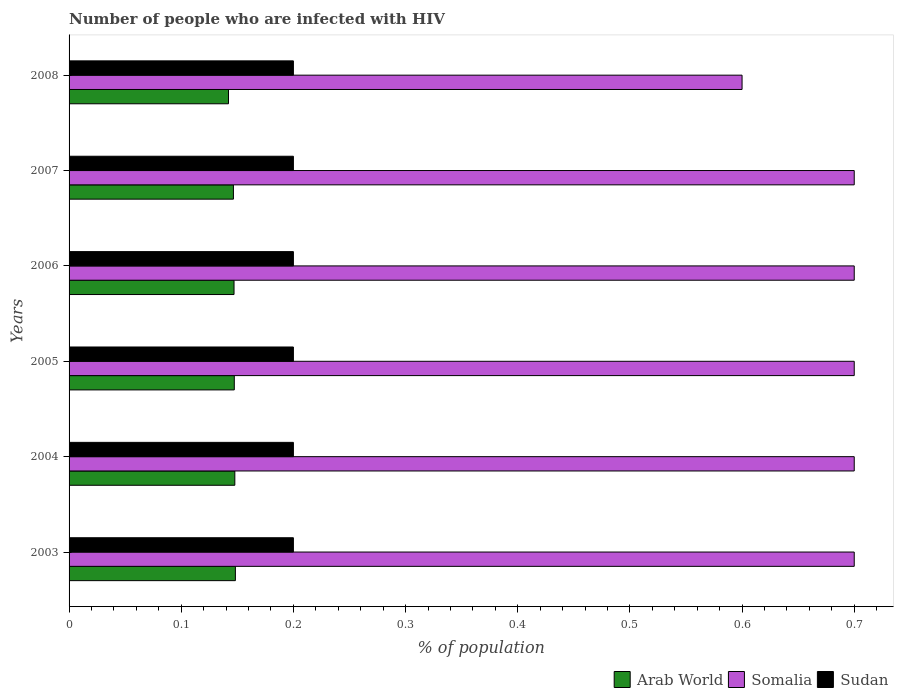How many different coloured bars are there?
Give a very brief answer. 3. Are the number of bars on each tick of the Y-axis equal?
Keep it short and to the point. Yes. How many bars are there on the 6th tick from the bottom?
Your answer should be compact. 3. What is the label of the 1st group of bars from the top?
Provide a succinct answer. 2008. What is the percentage of HIV infected population in in Arab World in 2003?
Your response must be concise. 0.15. In which year was the percentage of HIV infected population in in Sudan maximum?
Make the answer very short. 2003. In which year was the percentage of HIV infected population in in Sudan minimum?
Offer a very short reply. 2003. What is the total percentage of HIV infected population in in Arab World in the graph?
Offer a very short reply. 0.88. What is the difference between the percentage of HIV infected population in in Somalia in 2003 and that in 2005?
Your answer should be compact. 0. What is the difference between the percentage of HIV infected population in in Sudan in 2006 and the percentage of HIV infected population in in Arab World in 2007?
Make the answer very short. 0.05. What is the average percentage of HIV infected population in in Sudan per year?
Provide a short and direct response. 0.2. In the year 2006, what is the difference between the percentage of HIV infected population in in Somalia and percentage of HIV infected population in in Sudan?
Your answer should be very brief. 0.5. What is the difference between the highest and the lowest percentage of HIV infected population in in Arab World?
Make the answer very short. 0.01. Is the sum of the percentage of HIV infected population in in Sudan in 2003 and 2004 greater than the maximum percentage of HIV infected population in in Somalia across all years?
Make the answer very short. No. What does the 2nd bar from the top in 2008 represents?
Provide a short and direct response. Somalia. What does the 2nd bar from the bottom in 2003 represents?
Your answer should be very brief. Somalia. How many bars are there?
Your answer should be very brief. 18. Are the values on the major ticks of X-axis written in scientific E-notation?
Provide a succinct answer. No. Does the graph contain grids?
Your answer should be compact. No. How many legend labels are there?
Offer a terse response. 3. How are the legend labels stacked?
Provide a succinct answer. Horizontal. What is the title of the graph?
Provide a short and direct response. Number of people who are infected with HIV. What is the label or title of the X-axis?
Offer a terse response. % of population. What is the label or title of the Y-axis?
Your answer should be very brief. Years. What is the % of population of Arab World in 2003?
Your response must be concise. 0.15. What is the % of population of Somalia in 2003?
Provide a succinct answer. 0.7. What is the % of population in Sudan in 2003?
Offer a very short reply. 0.2. What is the % of population in Arab World in 2004?
Give a very brief answer. 0.15. What is the % of population in Arab World in 2005?
Make the answer very short. 0.15. What is the % of population of Somalia in 2005?
Your answer should be very brief. 0.7. What is the % of population of Sudan in 2005?
Ensure brevity in your answer.  0.2. What is the % of population in Arab World in 2006?
Offer a very short reply. 0.15. What is the % of population of Somalia in 2006?
Offer a terse response. 0.7. What is the % of population of Sudan in 2006?
Your answer should be very brief. 0.2. What is the % of population in Arab World in 2007?
Provide a short and direct response. 0.15. What is the % of population of Arab World in 2008?
Your response must be concise. 0.14. What is the % of population of Somalia in 2008?
Keep it short and to the point. 0.6. What is the % of population of Sudan in 2008?
Provide a succinct answer. 0.2. Across all years, what is the maximum % of population in Arab World?
Provide a short and direct response. 0.15. Across all years, what is the maximum % of population of Sudan?
Give a very brief answer. 0.2. Across all years, what is the minimum % of population of Arab World?
Provide a short and direct response. 0.14. Across all years, what is the minimum % of population in Sudan?
Keep it short and to the point. 0.2. What is the total % of population in Arab World in the graph?
Make the answer very short. 0.88. What is the total % of population in Somalia in the graph?
Your answer should be very brief. 4.1. What is the total % of population of Sudan in the graph?
Your answer should be very brief. 1.2. What is the difference between the % of population in Somalia in 2003 and that in 2004?
Provide a succinct answer. 0. What is the difference between the % of population in Sudan in 2003 and that in 2004?
Keep it short and to the point. 0. What is the difference between the % of population in Arab World in 2003 and that in 2005?
Offer a terse response. 0. What is the difference between the % of population in Somalia in 2003 and that in 2005?
Offer a terse response. 0. What is the difference between the % of population in Arab World in 2003 and that in 2006?
Keep it short and to the point. 0. What is the difference between the % of population of Somalia in 2003 and that in 2006?
Keep it short and to the point. 0. What is the difference between the % of population of Arab World in 2003 and that in 2007?
Make the answer very short. 0. What is the difference between the % of population of Somalia in 2003 and that in 2007?
Offer a terse response. 0. What is the difference between the % of population of Arab World in 2003 and that in 2008?
Make the answer very short. 0.01. What is the difference between the % of population in Sudan in 2003 and that in 2008?
Offer a terse response. 0. What is the difference between the % of population in Somalia in 2004 and that in 2005?
Keep it short and to the point. 0. What is the difference between the % of population in Arab World in 2004 and that in 2006?
Your response must be concise. 0. What is the difference between the % of population in Somalia in 2004 and that in 2006?
Keep it short and to the point. 0. What is the difference between the % of population of Arab World in 2004 and that in 2007?
Make the answer very short. 0. What is the difference between the % of population in Somalia in 2004 and that in 2007?
Provide a succinct answer. 0. What is the difference between the % of population in Arab World in 2004 and that in 2008?
Give a very brief answer. 0.01. What is the difference between the % of population of Arab World in 2005 and that in 2006?
Make the answer very short. 0. What is the difference between the % of population of Somalia in 2005 and that in 2006?
Make the answer very short. 0. What is the difference between the % of population in Sudan in 2005 and that in 2006?
Ensure brevity in your answer.  0. What is the difference between the % of population in Arab World in 2005 and that in 2007?
Offer a very short reply. 0. What is the difference between the % of population of Sudan in 2005 and that in 2007?
Provide a short and direct response. 0. What is the difference between the % of population of Arab World in 2005 and that in 2008?
Your response must be concise. 0.01. What is the difference between the % of population in Somalia in 2005 and that in 2008?
Make the answer very short. 0.1. What is the difference between the % of population in Sudan in 2005 and that in 2008?
Ensure brevity in your answer.  0. What is the difference between the % of population of Somalia in 2006 and that in 2007?
Provide a short and direct response. 0. What is the difference between the % of population of Sudan in 2006 and that in 2007?
Provide a succinct answer. 0. What is the difference between the % of population in Arab World in 2006 and that in 2008?
Give a very brief answer. 0. What is the difference between the % of population of Arab World in 2007 and that in 2008?
Give a very brief answer. 0. What is the difference between the % of population of Somalia in 2007 and that in 2008?
Give a very brief answer. 0.1. What is the difference between the % of population of Sudan in 2007 and that in 2008?
Give a very brief answer. 0. What is the difference between the % of population of Arab World in 2003 and the % of population of Somalia in 2004?
Make the answer very short. -0.55. What is the difference between the % of population in Arab World in 2003 and the % of population in Sudan in 2004?
Offer a very short reply. -0.05. What is the difference between the % of population of Somalia in 2003 and the % of population of Sudan in 2004?
Give a very brief answer. 0.5. What is the difference between the % of population of Arab World in 2003 and the % of population of Somalia in 2005?
Provide a short and direct response. -0.55. What is the difference between the % of population of Arab World in 2003 and the % of population of Sudan in 2005?
Keep it short and to the point. -0.05. What is the difference between the % of population of Somalia in 2003 and the % of population of Sudan in 2005?
Your answer should be very brief. 0.5. What is the difference between the % of population in Arab World in 2003 and the % of population in Somalia in 2006?
Make the answer very short. -0.55. What is the difference between the % of population in Arab World in 2003 and the % of population in Sudan in 2006?
Keep it short and to the point. -0.05. What is the difference between the % of population of Arab World in 2003 and the % of population of Somalia in 2007?
Your response must be concise. -0.55. What is the difference between the % of population of Arab World in 2003 and the % of population of Sudan in 2007?
Give a very brief answer. -0.05. What is the difference between the % of population of Somalia in 2003 and the % of population of Sudan in 2007?
Provide a short and direct response. 0.5. What is the difference between the % of population of Arab World in 2003 and the % of population of Somalia in 2008?
Keep it short and to the point. -0.45. What is the difference between the % of population in Arab World in 2003 and the % of population in Sudan in 2008?
Give a very brief answer. -0.05. What is the difference between the % of population of Arab World in 2004 and the % of population of Somalia in 2005?
Make the answer very short. -0.55. What is the difference between the % of population in Arab World in 2004 and the % of population in Sudan in 2005?
Your response must be concise. -0.05. What is the difference between the % of population of Arab World in 2004 and the % of population of Somalia in 2006?
Offer a terse response. -0.55. What is the difference between the % of population of Arab World in 2004 and the % of population of Sudan in 2006?
Make the answer very short. -0.05. What is the difference between the % of population in Arab World in 2004 and the % of population in Somalia in 2007?
Provide a short and direct response. -0.55. What is the difference between the % of population of Arab World in 2004 and the % of population of Sudan in 2007?
Your response must be concise. -0.05. What is the difference between the % of population of Somalia in 2004 and the % of population of Sudan in 2007?
Your response must be concise. 0.5. What is the difference between the % of population in Arab World in 2004 and the % of population in Somalia in 2008?
Provide a succinct answer. -0.45. What is the difference between the % of population in Arab World in 2004 and the % of population in Sudan in 2008?
Your response must be concise. -0.05. What is the difference between the % of population in Arab World in 2005 and the % of population in Somalia in 2006?
Keep it short and to the point. -0.55. What is the difference between the % of population of Arab World in 2005 and the % of population of Sudan in 2006?
Your response must be concise. -0.05. What is the difference between the % of population in Somalia in 2005 and the % of population in Sudan in 2006?
Make the answer very short. 0.5. What is the difference between the % of population of Arab World in 2005 and the % of population of Somalia in 2007?
Offer a very short reply. -0.55. What is the difference between the % of population in Arab World in 2005 and the % of population in Sudan in 2007?
Your answer should be very brief. -0.05. What is the difference between the % of population of Somalia in 2005 and the % of population of Sudan in 2007?
Your answer should be very brief. 0.5. What is the difference between the % of population in Arab World in 2005 and the % of population in Somalia in 2008?
Ensure brevity in your answer.  -0.45. What is the difference between the % of population in Arab World in 2005 and the % of population in Sudan in 2008?
Your answer should be very brief. -0.05. What is the difference between the % of population of Somalia in 2005 and the % of population of Sudan in 2008?
Offer a terse response. 0.5. What is the difference between the % of population of Arab World in 2006 and the % of population of Somalia in 2007?
Your answer should be compact. -0.55. What is the difference between the % of population of Arab World in 2006 and the % of population of Sudan in 2007?
Your response must be concise. -0.05. What is the difference between the % of population of Arab World in 2006 and the % of population of Somalia in 2008?
Offer a terse response. -0.45. What is the difference between the % of population in Arab World in 2006 and the % of population in Sudan in 2008?
Give a very brief answer. -0.05. What is the difference between the % of population of Arab World in 2007 and the % of population of Somalia in 2008?
Offer a terse response. -0.45. What is the difference between the % of population of Arab World in 2007 and the % of population of Sudan in 2008?
Offer a very short reply. -0.05. What is the difference between the % of population of Somalia in 2007 and the % of population of Sudan in 2008?
Your answer should be very brief. 0.5. What is the average % of population of Arab World per year?
Your answer should be compact. 0.15. What is the average % of population of Somalia per year?
Your answer should be very brief. 0.68. What is the average % of population in Sudan per year?
Your answer should be compact. 0.2. In the year 2003, what is the difference between the % of population of Arab World and % of population of Somalia?
Provide a short and direct response. -0.55. In the year 2003, what is the difference between the % of population of Arab World and % of population of Sudan?
Give a very brief answer. -0.05. In the year 2003, what is the difference between the % of population in Somalia and % of population in Sudan?
Provide a short and direct response. 0.5. In the year 2004, what is the difference between the % of population of Arab World and % of population of Somalia?
Keep it short and to the point. -0.55. In the year 2004, what is the difference between the % of population in Arab World and % of population in Sudan?
Provide a succinct answer. -0.05. In the year 2005, what is the difference between the % of population in Arab World and % of population in Somalia?
Offer a very short reply. -0.55. In the year 2005, what is the difference between the % of population of Arab World and % of population of Sudan?
Your response must be concise. -0.05. In the year 2006, what is the difference between the % of population of Arab World and % of population of Somalia?
Provide a short and direct response. -0.55. In the year 2006, what is the difference between the % of population in Arab World and % of population in Sudan?
Provide a short and direct response. -0.05. In the year 2006, what is the difference between the % of population of Somalia and % of population of Sudan?
Your answer should be compact. 0.5. In the year 2007, what is the difference between the % of population in Arab World and % of population in Somalia?
Give a very brief answer. -0.55. In the year 2007, what is the difference between the % of population of Arab World and % of population of Sudan?
Your answer should be compact. -0.05. In the year 2008, what is the difference between the % of population in Arab World and % of population in Somalia?
Give a very brief answer. -0.46. In the year 2008, what is the difference between the % of population in Arab World and % of population in Sudan?
Provide a short and direct response. -0.06. In the year 2008, what is the difference between the % of population of Somalia and % of population of Sudan?
Provide a short and direct response. 0.4. What is the ratio of the % of population of Somalia in 2003 to that in 2004?
Provide a short and direct response. 1. What is the ratio of the % of population in Sudan in 2003 to that in 2004?
Offer a terse response. 1. What is the ratio of the % of population of Arab World in 2003 to that in 2005?
Your response must be concise. 1.01. What is the ratio of the % of population of Somalia in 2003 to that in 2005?
Offer a terse response. 1. What is the ratio of the % of population of Arab World in 2003 to that in 2006?
Your response must be concise. 1.01. What is the ratio of the % of population in Somalia in 2003 to that in 2006?
Your response must be concise. 1. What is the ratio of the % of population of Sudan in 2003 to that in 2006?
Your response must be concise. 1. What is the ratio of the % of population in Somalia in 2003 to that in 2007?
Your answer should be very brief. 1. What is the ratio of the % of population of Sudan in 2003 to that in 2007?
Keep it short and to the point. 1. What is the ratio of the % of population of Arab World in 2003 to that in 2008?
Give a very brief answer. 1.04. What is the ratio of the % of population of Somalia in 2003 to that in 2008?
Your response must be concise. 1.17. What is the ratio of the % of population in Arab World in 2004 to that in 2005?
Your answer should be very brief. 1. What is the ratio of the % of population of Arab World in 2004 to that in 2006?
Your answer should be very brief. 1. What is the ratio of the % of population in Somalia in 2004 to that in 2006?
Make the answer very short. 1. What is the ratio of the % of population in Arab World in 2004 to that in 2007?
Your answer should be very brief. 1.01. What is the ratio of the % of population of Arab World in 2004 to that in 2008?
Keep it short and to the point. 1.04. What is the ratio of the % of population in Sudan in 2004 to that in 2008?
Your answer should be compact. 1. What is the ratio of the % of population of Arab World in 2005 to that in 2007?
Your answer should be very brief. 1.01. What is the ratio of the % of population of Somalia in 2005 to that in 2007?
Provide a short and direct response. 1. What is the ratio of the % of population in Sudan in 2005 to that in 2007?
Provide a short and direct response. 1. What is the ratio of the % of population of Arab World in 2005 to that in 2008?
Give a very brief answer. 1.04. What is the ratio of the % of population of Somalia in 2005 to that in 2008?
Offer a terse response. 1.17. What is the ratio of the % of population of Sudan in 2005 to that in 2008?
Offer a very short reply. 1. What is the ratio of the % of population in Arab World in 2006 to that in 2007?
Your answer should be very brief. 1. What is the ratio of the % of population in Arab World in 2006 to that in 2008?
Offer a terse response. 1.03. What is the ratio of the % of population in Somalia in 2006 to that in 2008?
Make the answer very short. 1.17. What is the ratio of the % of population in Arab World in 2007 to that in 2008?
Give a very brief answer. 1.03. What is the ratio of the % of population in Somalia in 2007 to that in 2008?
Your response must be concise. 1.17. What is the difference between the highest and the second highest % of population of Arab World?
Your answer should be very brief. 0. What is the difference between the highest and the second highest % of population in Somalia?
Make the answer very short. 0. What is the difference between the highest and the lowest % of population of Arab World?
Provide a succinct answer. 0.01. What is the difference between the highest and the lowest % of population in Somalia?
Make the answer very short. 0.1. What is the difference between the highest and the lowest % of population in Sudan?
Keep it short and to the point. 0. 